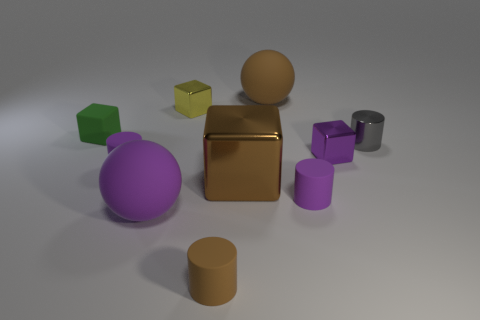Subtract all cyan cylinders. Subtract all red blocks. How many cylinders are left? 4 Subtract all balls. How many objects are left? 8 Add 5 big spheres. How many big spheres are left? 7 Add 5 big cubes. How many big cubes exist? 6 Subtract 0 blue spheres. How many objects are left? 10 Subtract all big blue metallic spheres. Subtract all large brown metallic blocks. How many objects are left? 9 